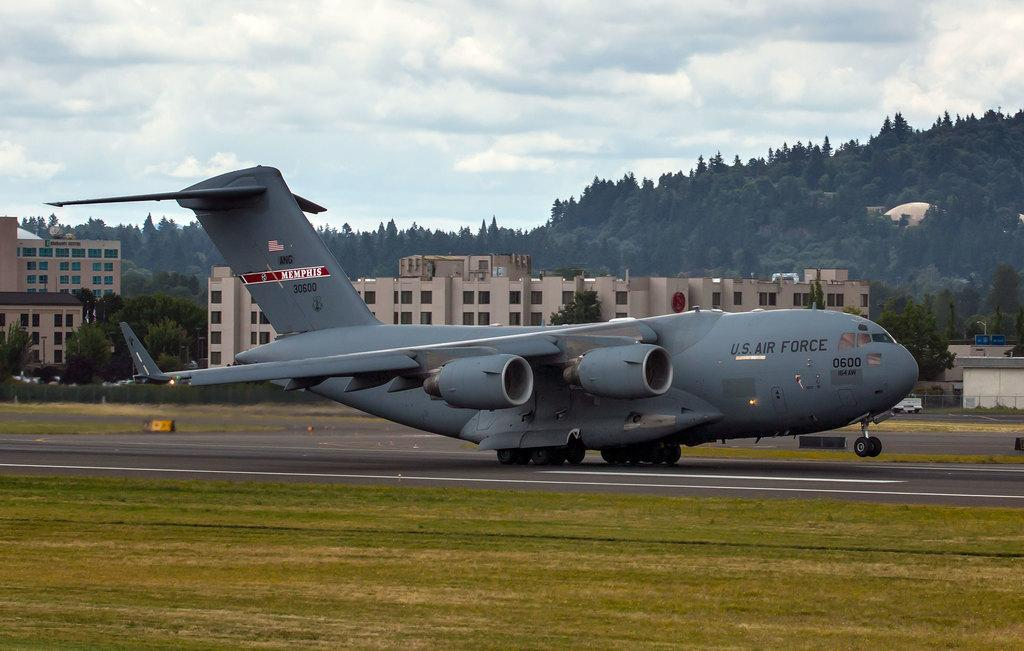<image>
Offer a succinct explanation of the picture presented. A U.S. Air Force plane has Memphis in red and white on the tail. 